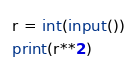<code> <loc_0><loc_0><loc_500><loc_500><_Python_>r = int(input())
print(r**2)</code> 